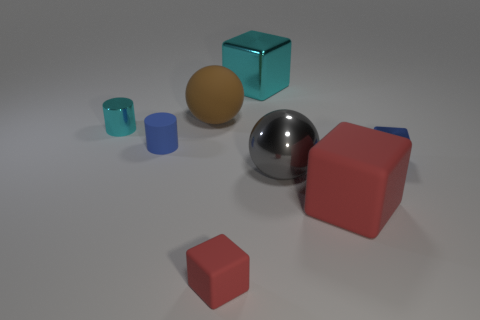Subtract all green cubes. Subtract all yellow cylinders. How many cubes are left? 4 Add 1 small red matte cubes. How many objects exist? 9 Subtract all cylinders. How many objects are left? 6 Add 6 cylinders. How many cylinders exist? 8 Subtract 0 cyan spheres. How many objects are left? 8 Subtract all large gray objects. Subtract all tiny cyan things. How many objects are left? 6 Add 6 big metallic balls. How many big metallic balls are left? 7 